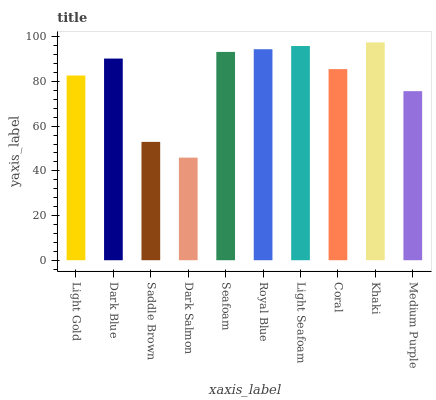Is Dark Salmon the minimum?
Answer yes or no. Yes. Is Khaki the maximum?
Answer yes or no. Yes. Is Dark Blue the minimum?
Answer yes or no. No. Is Dark Blue the maximum?
Answer yes or no. No. Is Dark Blue greater than Light Gold?
Answer yes or no. Yes. Is Light Gold less than Dark Blue?
Answer yes or no. Yes. Is Light Gold greater than Dark Blue?
Answer yes or no. No. Is Dark Blue less than Light Gold?
Answer yes or no. No. Is Dark Blue the high median?
Answer yes or no. Yes. Is Coral the low median?
Answer yes or no. Yes. Is Khaki the high median?
Answer yes or no. No. Is Khaki the low median?
Answer yes or no. No. 